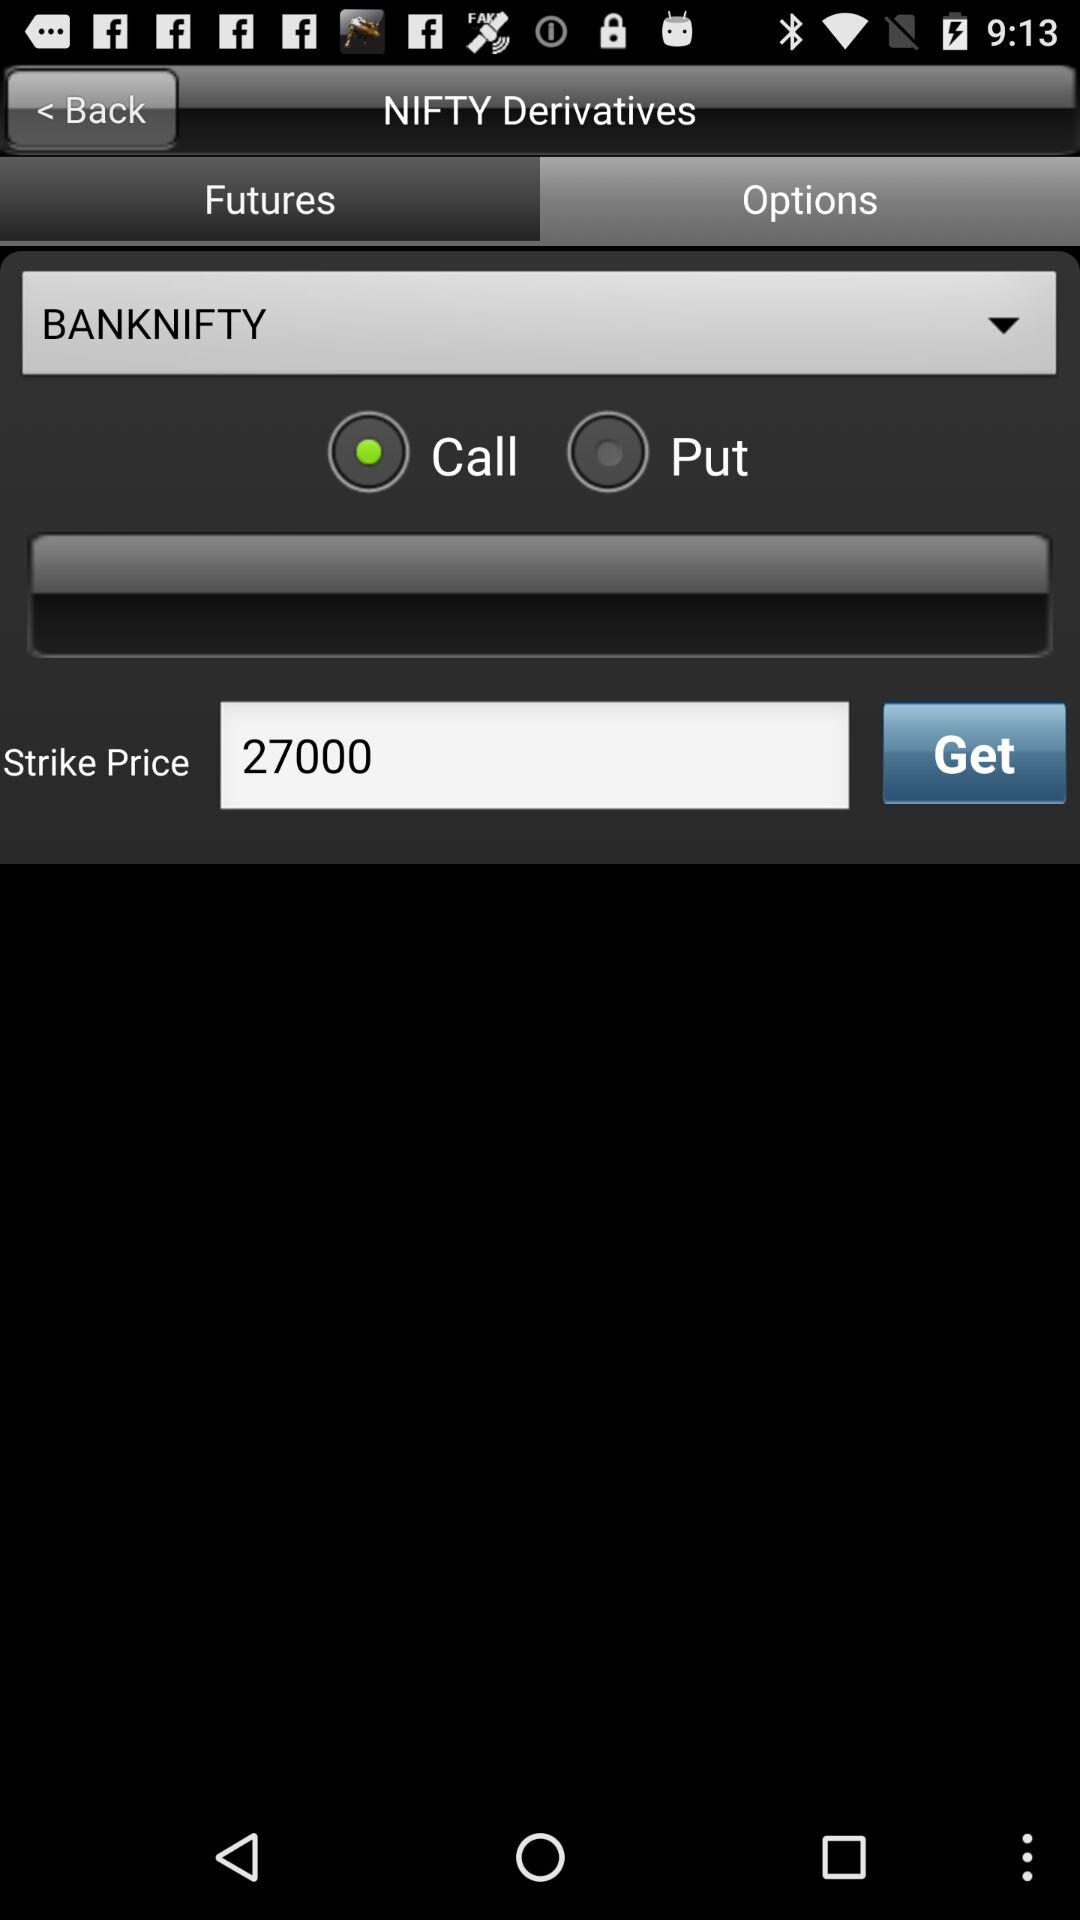What is the strike price? The strike price is 27000. 